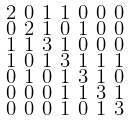Convert formula to latex. <formula><loc_0><loc_0><loc_500><loc_500>\begin{smallmatrix} 2 & 0 & 1 & 1 & 0 & 0 & 0 \\ 0 & 2 & 1 & 0 & 1 & 0 & 0 \\ 1 & 1 & 3 & 1 & 0 & 0 & 0 \\ 1 & 0 & 1 & 3 & 1 & 1 & 1 \\ 0 & 1 & 0 & 1 & 3 & 1 & 0 \\ 0 & 0 & 0 & 1 & 1 & 3 & 1 \\ 0 & 0 & 0 & 1 & 0 & 1 & 3 \end{smallmatrix}</formula> 